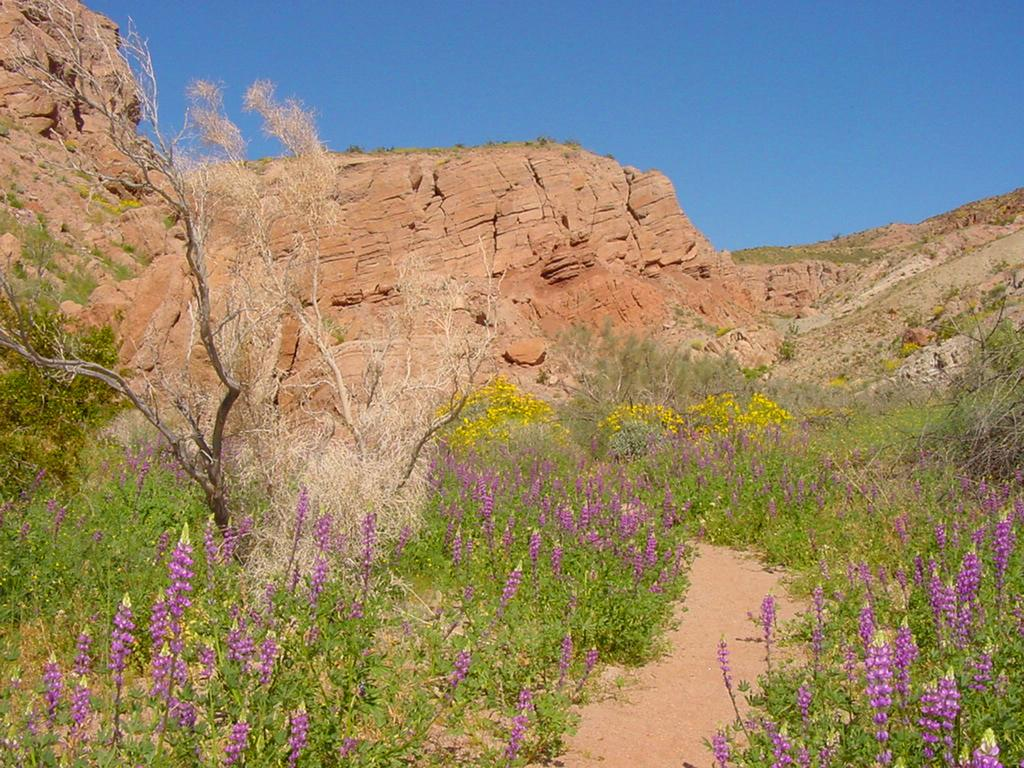What type of plants can be seen in the image? There are plants with flowers in the image. What can be seen in the background of the image? There are trees, mountains, and the sky visible in the background of the image. Where is the pen located in the image? There is no pen present in the image. What type of throne can be seen in the image? There is no throne present in the image. 